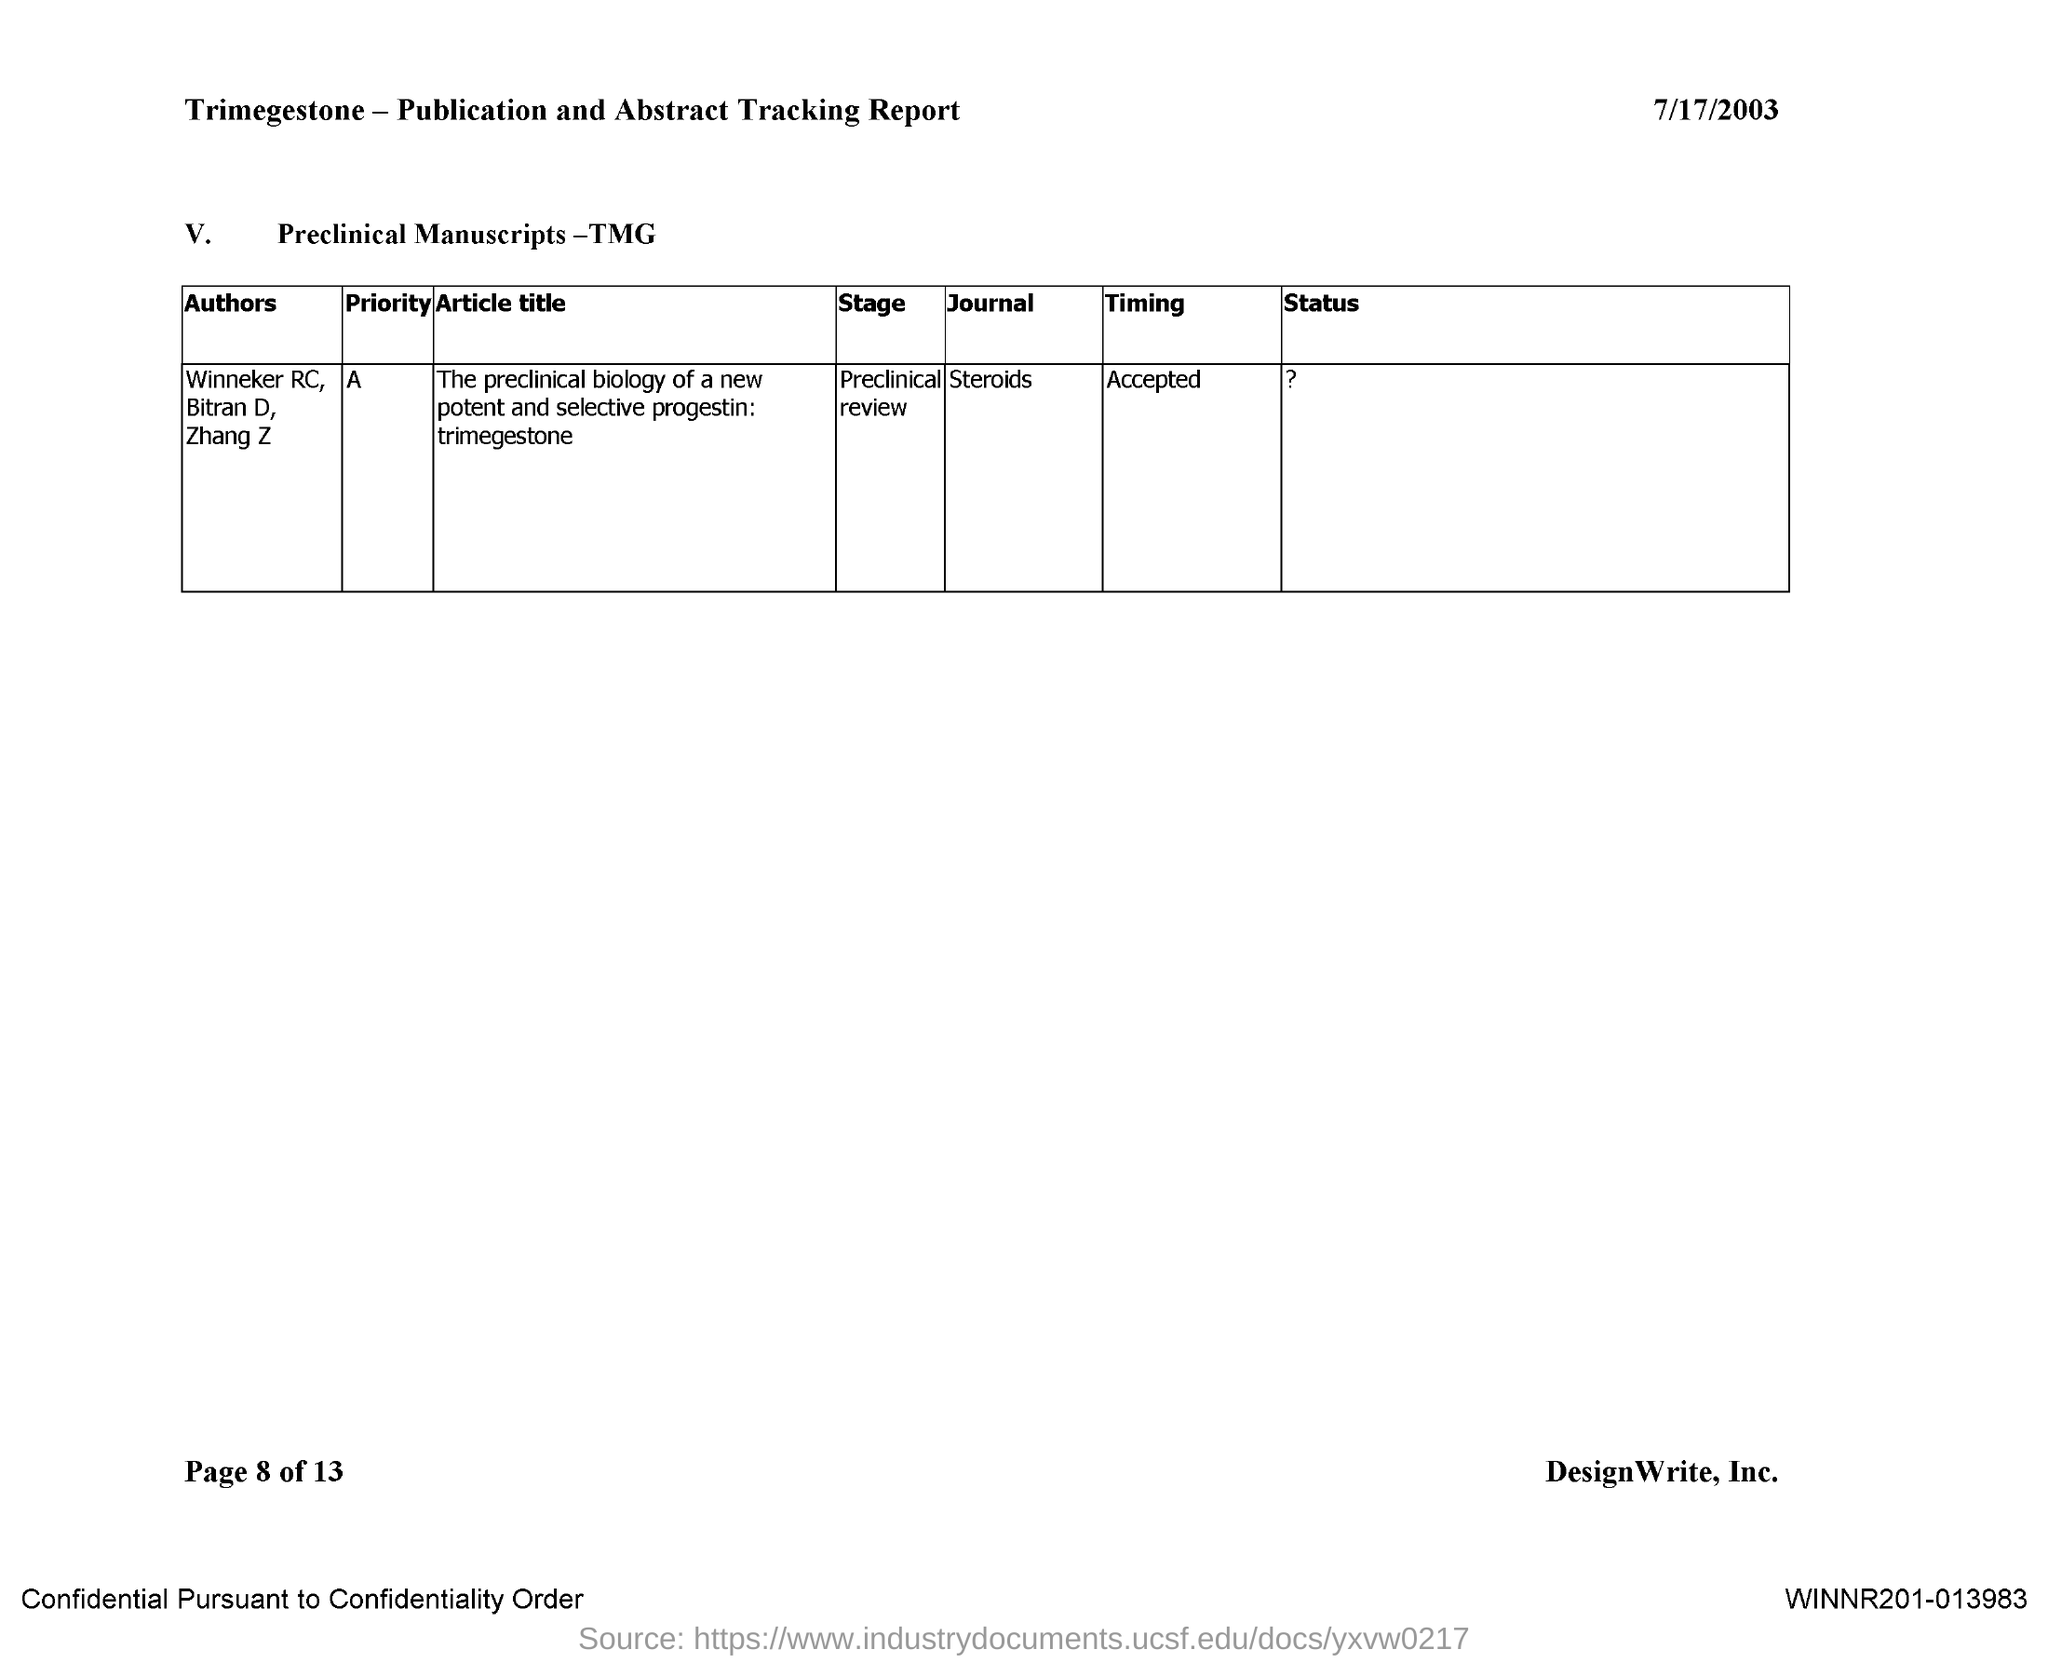What is the date mentioned in the document?
Provide a succinct answer. 7/17/2003. What is the name of the journal?
Your answer should be very brief. Steroids. Which alphabet represents the priority of the journal Steroids?
Keep it short and to the point. A. 